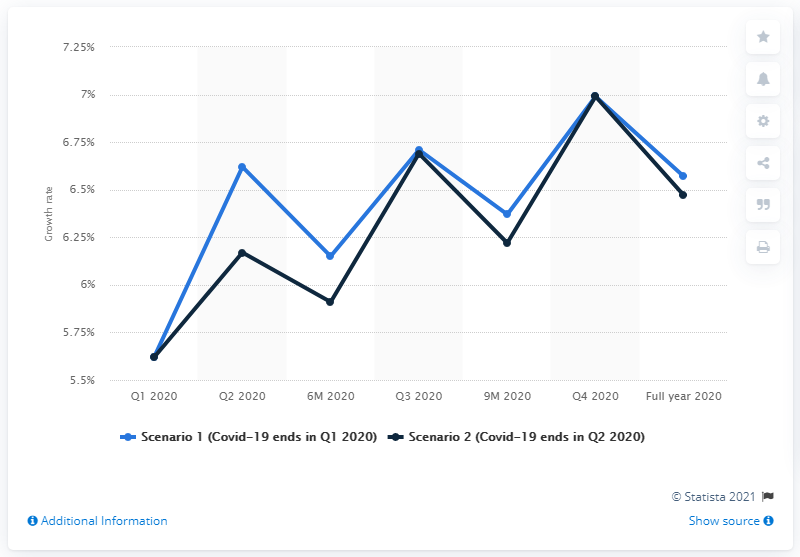Give some essential details in this illustration. The projected increase in the services sector for the second quarter of 2020 was 6.47%. 